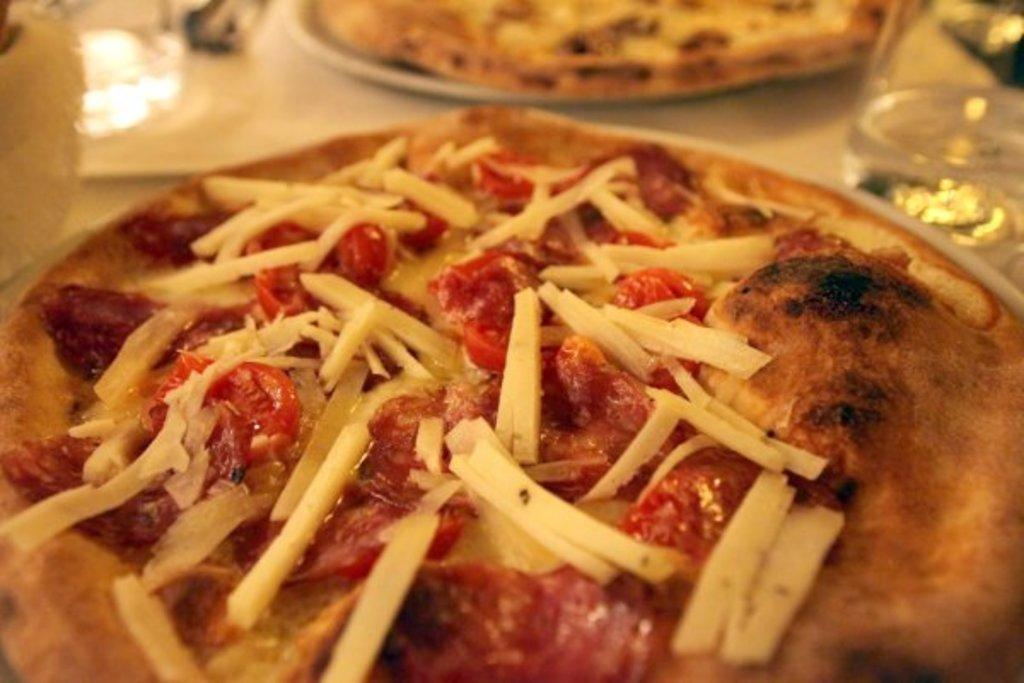What piece of furniture is present in the image? There is a table in the image. What is placed on the table? There are two plates on the table. What food is on the plates? The plates contain pizzas. What else can be seen on the table? There are glasses on the table. How does the sheet fall off the table in the image? There is no sheet present in the image, so it cannot fall off the table. 